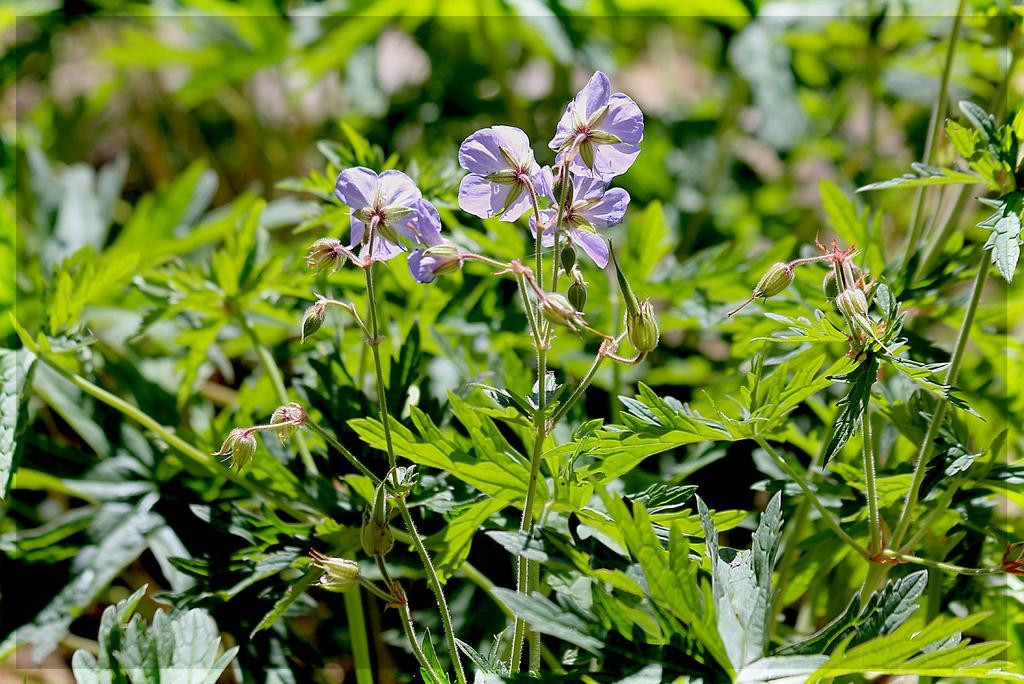Could you give a brief overview of what you see in this image? In this picture we can see flowers and buds to the stems. Behind the flowers there are plants. 